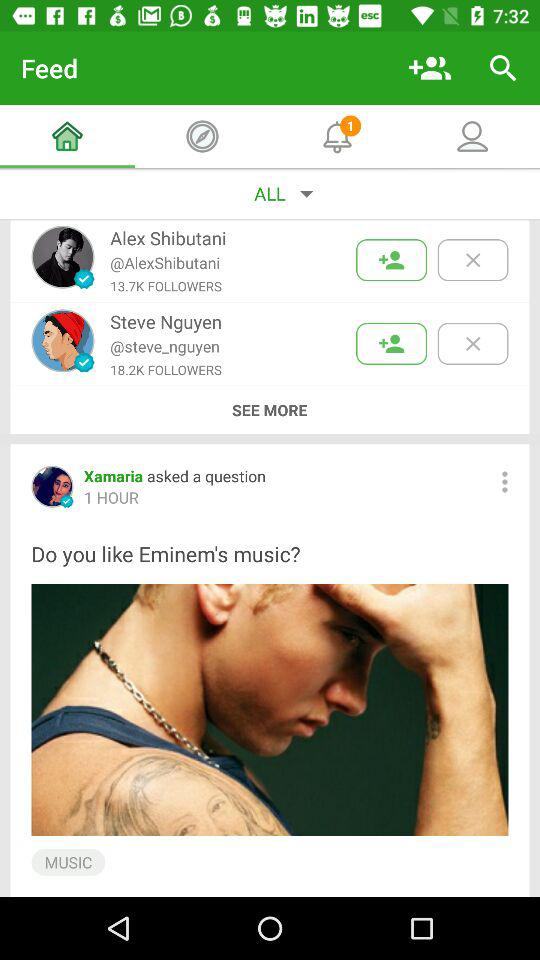How many people are following Steve Nguyen?
Answer the question using a single word or phrase. 18.2K 